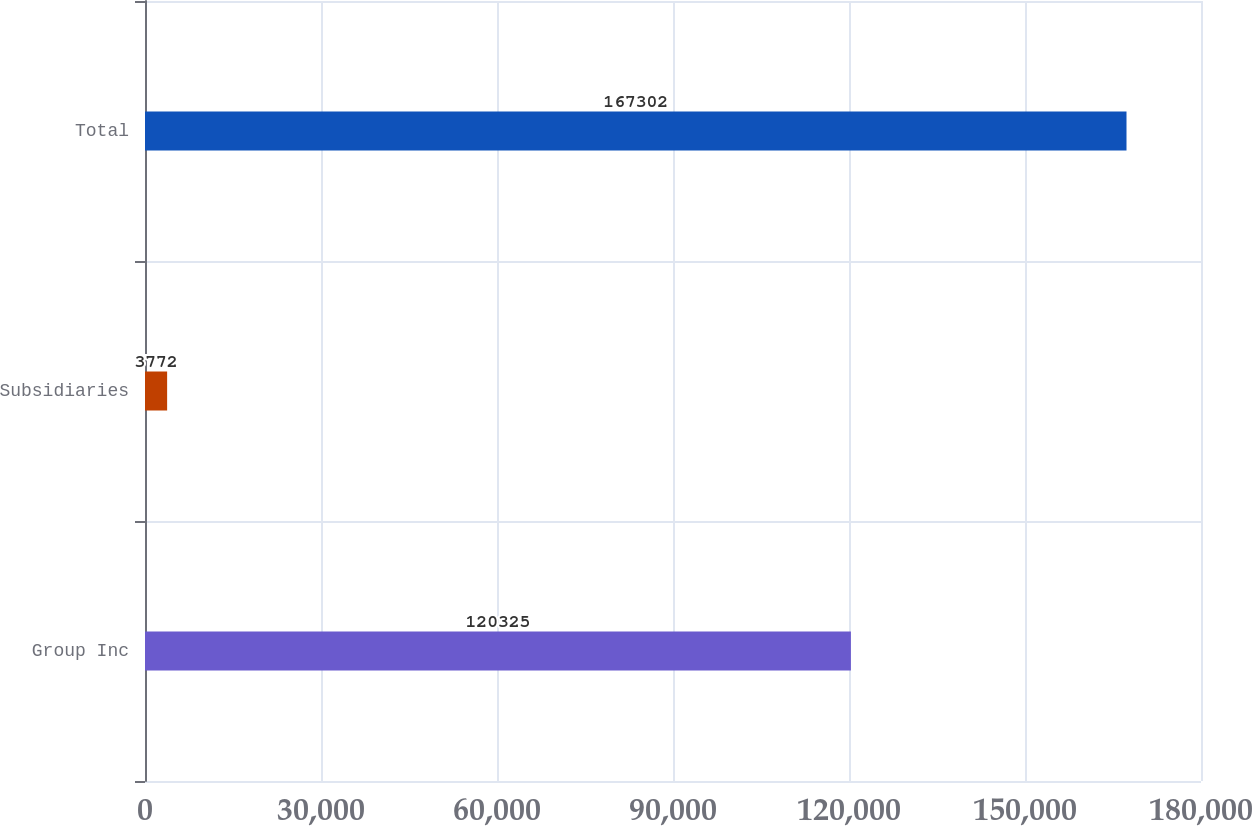Convert chart. <chart><loc_0><loc_0><loc_500><loc_500><bar_chart><fcel>Group Inc<fcel>Subsidiaries<fcel>Total<nl><fcel>120325<fcel>3772<fcel>167302<nl></chart> 